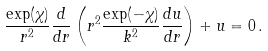Convert formula to latex. <formula><loc_0><loc_0><loc_500><loc_500>\frac { \exp ( \chi ) } { r ^ { 2 } } \frac { d } { d r } \left ( r ^ { 2 } \frac { \exp ( - \chi ) } { k ^ { 2 } } \frac { d u } { d r } \right ) + u = 0 \, .</formula> 